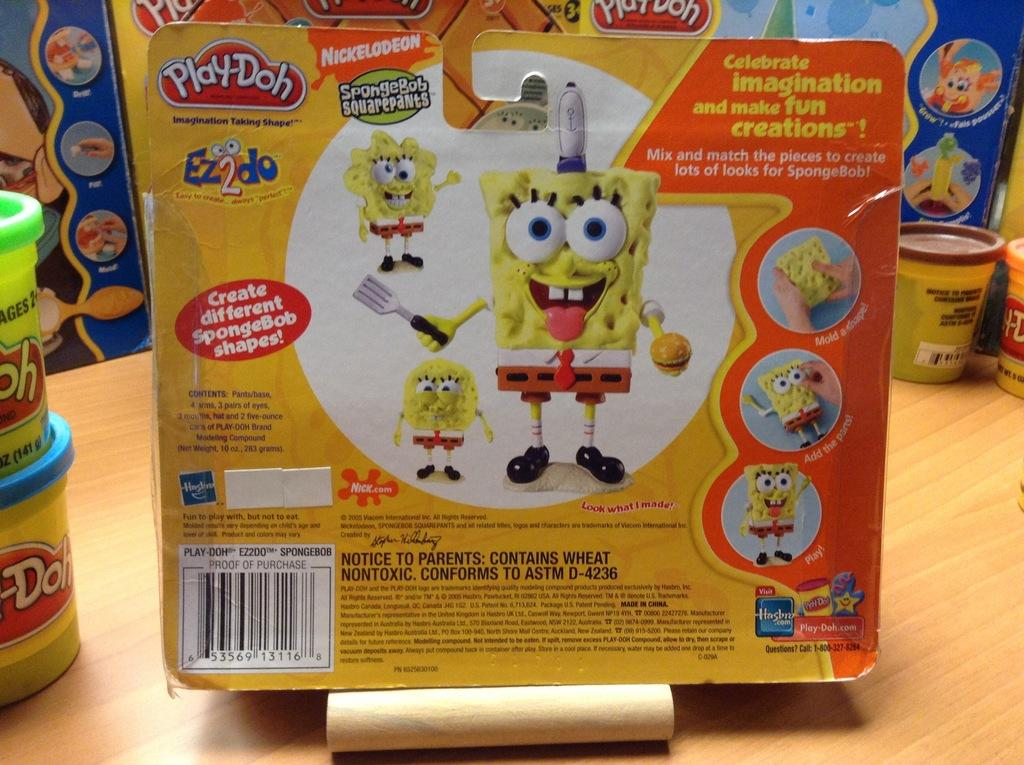Who is present in the image? There are kids in the image. What are the kids doing in the image? The kids are playing with toys. Can you describe any other objects in the image? There are cups on a table in the image. What type of toothbrush is the duck using in the image? There is no toothbrush or duck present in the image. 